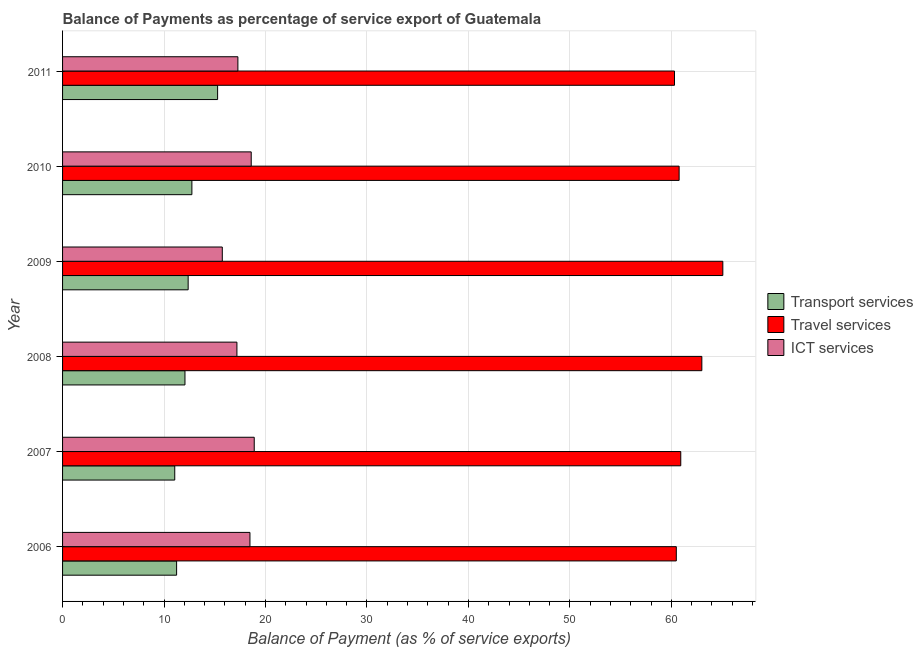How many different coloured bars are there?
Offer a very short reply. 3. How many groups of bars are there?
Provide a succinct answer. 6. Are the number of bars per tick equal to the number of legend labels?
Your answer should be very brief. Yes. Are the number of bars on each tick of the Y-axis equal?
Keep it short and to the point. Yes. How many bars are there on the 2nd tick from the top?
Make the answer very short. 3. What is the label of the 3rd group of bars from the top?
Your answer should be very brief. 2009. In how many cases, is the number of bars for a given year not equal to the number of legend labels?
Your answer should be compact. 0. What is the balance of payment of travel services in 2011?
Your response must be concise. 60.31. Across all years, what is the maximum balance of payment of transport services?
Make the answer very short. 15.28. Across all years, what is the minimum balance of payment of transport services?
Keep it short and to the point. 11.06. In which year was the balance of payment of ict services minimum?
Give a very brief answer. 2009. What is the total balance of payment of transport services in the graph?
Provide a short and direct response. 74.76. What is the difference between the balance of payment of transport services in 2007 and that in 2009?
Offer a terse response. -1.32. What is the difference between the balance of payment of ict services in 2008 and the balance of payment of transport services in 2011?
Provide a succinct answer. 1.9. What is the average balance of payment of travel services per year?
Provide a short and direct response. 61.76. In the year 2006, what is the difference between the balance of payment of travel services and balance of payment of ict services?
Make the answer very short. 42.02. Is the difference between the balance of payment of travel services in 2007 and 2008 greater than the difference between the balance of payment of ict services in 2007 and 2008?
Offer a very short reply. No. What is the difference between the highest and the second highest balance of payment of ict services?
Provide a short and direct response. 0.3. What is the difference between the highest and the lowest balance of payment of travel services?
Keep it short and to the point. 4.76. Is the sum of the balance of payment of ict services in 2006 and 2007 greater than the maximum balance of payment of travel services across all years?
Give a very brief answer. No. What does the 2nd bar from the top in 2009 represents?
Give a very brief answer. Travel services. What does the 3rd bar from the bottom in 2010 represents?
Provide a succinct answer. ICT services. How many bars are there?
Keep it short and to the point. 18. What is the difference between two consecutive major ticks on the X-axis?
Provide a short and direct response. 10. Does the graph contain any zero values?
Your response must be concise. No. Does the graph contain grids?
Your answer should be compact. Yes. Where does the legend appear in the graph?
Provide a short and direct response. Center right. How many legend labels are there?
Provide a succinct answer. 3. What is the title of the graph?
Offer a terse response. Balance of Payments as percentage of service export of Guatemala. What is the label or title of the X-axis?
Your response must be concise. Balance of Payment (as % of service exports). What is the Balance of Payment (as % of service exports) of Transport services in 2006?
Ensure brevity in your answer.  11.24. What is the Balance of Payment (as % of service exports) of Travel services in 2006?
Your answer should be compact. 60.48. What is the Balance of Payment (as % of service exports) of ICT services in 2006?
Offer a terse response. 18.47. What is the Balance of Payment (as % of service exports) of Transport services in 2007?
Offer a very short reply. 11.06. What is the Balance of Payment (as % of service exports) of Travel services in 2007?
Your response must be concise. 60.92. What is the Balance of Payment (as % of service exports) of ICT services in 2007?
Keep it short and to the point. 18.89. What is the Balance of Payment (as % of service exports) of Transport services in 2008?
Provide a short and direct response. 12.06. What is the Balance of Payment (as % of service exports) of Travel services in 2008?
Keep it short and to the point. 63. What is the Balance of Payment (as % of service exports) in ICT services in 2008?
Offer a very short reply. 17.18. What is the Balance of Payment (as % of service exports) of Transport services in 2009?
Provide a short and direct response. 12.38. What is the Balance of Payment (as % of service exports) of Travel services in 2009?
Make the answer very short. 65.07. What is the Balance of Payment (as % of service exports) of ICT services in 2009?
Offer a very short reply. 15.74. What is the Balance of Payment (as % of service exports) of Transport services in 2010?
Offer a terse response. 12.74. What is the Balance of Payment (as % of service exports) of Travel services in 2010?
Your response must be concise. 60.76. What is the Balance of Payment (as % of service exports) in ICT services in 2010?
Your answer should be compact. 18.59. What is the Balance of Payment (as % of service exports) in Transport services in 2011?
Make the answer very short. 15.28. What is the Balance of Payment (as % of service exports) in Travel services in 2011?
Keep it short and to the point. 60.31. What is the Balance of Payment (as % of service exports) of ICT services in 2011?
Provide a short and direct response. 17.28. Across all years, what is the maximum Balance of Payment (as % of service exports) of Transport services?
Provide a succinct answer. 15.28. Across all years, what is the maximum Balance of Payment (as % of service exports) of Travel services?
Offer a very short reply. 65.07. Across all years, what is the maximum Balance of Payment (as % of service exports) of ICT services?
Your response must be concise. 18.89. Across all years, what is the minimum Balance of Payment (as % of service exports) of Transport services?
Your response must be concise. 11.06. Across all years, what is the minimum Balance of Payment (as % of service exports) of Travel services?
Offer a terse response. 60.31. Across all years, what is the minimum Balance of Payment (as % of service exports) of ICT services?
Provide a short and direct response. 15.74. What is the total Balance of Payment (as % of service exports) in Transport services in the graph?
Your response must be concise. 74.76. What is the total Balance of Payment (as % of service exports) in Travel services in the graph?
Your response must be concise. 370.54. What is the total Balance of Payment (as % of service exports) of ICT services in the graph?
Ensure brevity in your answer.  106.15. What is the difference between the Balance of Payment (as % of service exports) of Transport services in 2006 and that in 2007?
Give a very brief answer. 0.18. What is the difference between the Balance of Payment (as % of service exports) of Travel services in 2006 and that in 2007?
Provide a succinct answer. -0.44. What is the difference between the Balance of Payment (as % of service exports) of ICT services in 2006 and that in 2007?
Make the answer very short. -0.42. What is the difference between the Balance of Payment (as % of service exports) of Transport services in 2006 and that in 2008?
Provide a short and direct response. -0.82. What is the difference between the Balance of Payment (as % of service exports) of Travel services in 2006 and that in 2008?
Offer a terse response. -2.52. What is the difference between the Balance of Payment (as % of service exports) of ICT services in 2006 and that in 2008?
Give a very brief answer. 1.28. What is the difference between the Balance of Payment (as % of service exports) in Transport services in 2006 and that in 2009?
Provide a short and direct response. -1.14. What is the difference between the Balance of Payment (as % of service exports) in Travel services in 2006 and that in 2009?
Ensure brevity in your answer.  -4.58. What is the difference between the Balance of Payment (as % of service exports) in ICT services in 2006 and that in 2009?
Make the answer very short. 2.73. What is the difference between the Balance of Payment (as % of service exports) of Transport services in 2006 and that in 2010?
Make the answer very short. -1.51. What is the difference between the Balance of Payment (as % of service exports) of Travel services in 2006 and that in 2010?
Keep it short and to the point. -0.28. What is the difference between the Balance of Payment (as % of service exports) of ICT services in 2006 and that in 2010?
Give a very brief answer. -0.12. What is the difference between the Balance of Payment (as % of service exports) in Transport services in 2006 and that in 2011?
Make the answer very short. -4.04. What is the difference between the Balance of Payment (as % of service exports) of Travel services in 2006 and that in 2011?
Provide a succinct answer. 0.18. What is the difference between the Balance of Payment (as % of service exports) in ICT services in 2006 and that in 2011?
Ensure brevity in your answer.  1.19. What is the difference between the Balance of Payment (as % of service exports) of Transport services in 2007 and that in 2008?
Offer a terse response. -1.01. What is the difference between the Balance of Payment (as % of service exports) of Travel services in 2007 and that in 2008?
Keep it short and to the point. -2.08. What is the difference between the Balance of Payment (as % of service exports) of ICT services in 2007 and that in 2008?
Ensure brevity in your answer.  1.71. What is the difference between the Balance of Payment (as % of service exports) of Transport services in 2007 and that in 2009?
Offer a terse response. -1.32. What is the difference between the Balance of Payment (as % of service exports) in Travel services in 2007 and that in 2009?
Your answer should be very brief. -4.14. What is the difference between the Balance of Payment (as % of service exports) of ICT services in 2007 and that in 2009?
Your response must be concise. 3.15. What is the difference between the Balance of Payment (as % of service exports) of Transport services in 2007 and that in 2010?
Provide a short and direct response. -1.69. What is the difference between the Balance of Payment (as % of service exports) of Travel services in 2007 and that in 2010?
Your response must be concise. 0.16. What is the difference between the Balance of Payment (as % of service exports) in ICT services in 2007 and that in 2010?
Your answer should be compact. 0.3. What is the difference between the Balance of Payment (as % of service exports) in Transport services in 2007 and that in 2011?
Your answer should be compact. -4.22. What is the difference between the Balance of Payment (as % of service exports) of Travel services in 2007 and that in 2011?
Offer a terse response. 0.62. What is the difference between the Balance of Payment (as % of service exports) in ICT services in 2007 and that in 2011?
Provide a succinct answer. 1.61. What is the difference between the Balance of Payment (as % of service exports) in Transport services in 2008 and that in 2009?
Ensure brevity in your answer.  -0.31. What is the difference between the Balance of Payment (as % of service exports) in Travel services in 2008 and that in 2009?
Provide a succinct answer. -2.07. What is the difference between the Balance of Payment (as % of service exports) of ICT services in 2008 and that in 2009?
Offer a terse response. 1.44. What is the difference between the Balance of Payment (as % of service exports) of Transport services in 2008 and that in 2010?
Give a very brief answer. -0.68. What is the difference between the Balance of Payment (as % of service exports) of Travel services in 2008 and that in 2010?
Offer a very short reply. 2.24. What is the difference between the Balance of Payment (as % of service exports) in ICT services in 2008 and that in 2010?
Offer a terse response. -1.41. What is the difference between the Balance of Payment (as % of service exports) of Transport services in 2008 and that in 2011?
Offer a very short reply. -3.22. What is the difference between the Balance of Payment (as % of service exports) in Travel services in 2008 and that in 2011?
Your response must be concise. 2.69. What is the difference between the Balance of Payment (as % of service exports) of ICT services in 2008 and that in 2011?
Offer a very short reply. -0.09. What is the difference between the Balance of Payment (as % of service exports) in Transport services in 2009 and that in 2010?
Provide a short and direct response. -0.37. What is the difference between the Balance of Payment (as % of service exports) of Travel services in 2009 and that in 2010?
Offer a very short reply. 4.31. What is the difference between the Balance of Payment (as % of service exports) in ICT services in 2009 and that in 2010?
Offer a terse response. -2.85. What is the difference between the Balance of Payment (as % of service exports) of Transport services in 2009 and that in 2011?
Ensure brevity in your answer.  -2.9. What is the difference between the Balance of Payment (as % of service exports) in Travel services in 2009 and that in 2011?
Give a very brief answer. 4.76. What is the difference between the Balance of Payment (as % of service exports) in ICT services in 2009 and that in 2011?
Keep it short and to the point. -1.54. What is the difference between the Balance of Payment (as % of service exports) in Transport services in 2010 and that in 2011?
Ensure brevity in your answer.  -2.53. What is the difference between the Balance of Payment (as % of service exports) of Travel services in 2010 and that in 2011?
Ensure brevity in your answer.  0.46. What is the difference between the Balance of Payment (as % of service exports) of ICT services in 2010 and that in 2011?
Offer a terse response. 1.31. What is the difference between the Balance of Payment (as % of service exports) in Transport services in 2006 and the Balance of Payment (as % of service exports) in Travel services in 2007?
Provide a succinct answer. -49.68. What is the difference between the Balance of Payment (as % of service exports) of Transport services in 2006 and the Balance of Payment (as % of service exports) of ICT services in 2007?
Your answer should be compact. -7.65. What is the difference between the Balance of Payment (as % of service exports) of Travel services in 2006 and the Balance of Payment (as % of service exports) of ICT services in 2007?
Make the answer very short. 41.6. What is the difference between the Balance of Payment (as % of service exports) of Transport services in 2006 and the Balance of Payment (as % of service exports) of Travel services in 2008?
Ensure brevity in your answer.  -51.76. What is the difference between the Balance of Payment (as % of service exports) in Transport services in 2006 and the Balance of Payment (as % of service exports) in ICT services in 2008?
Provide a short and direct response. -5.95. What is the difference between the Balance of Payment (as % of service exports) of Travel services in 2006 and the Balance of Payment (as % of service exports) of ICT services in 2008?
Your response must be concise. 43.3. What is the difference between the Balance of Payment (as % of service exports) in Transport services in 2006 and the Balance of Payment (as % of service exports) in Travel services in 2009?
Ensure brevity in your answer.  -53.83. What is the difference between the Balance of Payment (as % of service exports) in Transport services in 2006 and the Balance of Payment (as % of service exports) in ICT services in 2009?
Ensure brevity in your answer.  -4.5. What is the difference between the Balance of Payment (as % of service exports) of Travel services in 2006 and the Balance of Payment (as % of service exports) of ICT services in 2009?
Your answer should be compact. 44.74. What is the difference between the Balance of Payment (as % of service exports) of Transport services in 2006 and the Balance of Payment (as % of service exports) of Travel services in 2010?
Provide a succinct answer. -49.52. What is the difference between the Balance of Payment (as % of service exports) in Transport services in 2006 and the Balance of Payment (as % of service exports) in ICT services in 2010?
Your answer should be very brief. -7.35. What is the difference between the Balance of Payment (as % of service exports) in Travel services in 2006 and the Balance of Payment (as % of service exports) in ICT services in 2010?
Ensure brevity in your answer.  41.89. What is the difference between the Balance of Payment (as % of service exports) of Transport services in 2006 and the Balance of Payment (as % of service exports) of Travel services in 2011?
Make the answer very short. -49.07. What is the difference between the Balance of Payment (as % of service exports) of Transport services in 2006 and the Balance of Payment (as % of service exports) of ICT services in 2011?
Your answer should be compact. -6.04. What is the difference between the Balance of Payment (as % of service exports) of Travel services in 2006 and the Balance of Payment (as % of service exports) of ICT services in 2011?
Offer a very short reply. 43.21. What is the difference between the Balance of Payment (as % of service exports) of Transport services in 2007 and the Balance of Payment (as % of service exports) of Travel services in 2008?
Provide a short and direct response. -51.94. What is the difference between the Balance of Payment (as % of service exports) in Transport services in 2007 and the Balance of Payment (as % of service exports) in ICT services in 2008?
Give a very brief answer. -6.13. What is the difference between the Balance of Payment (as % of service exports) of Travel services in 2007 and the Balance of Payment (as % of service exports) of ICT services in 2008?
Give a very brief answer. 43.74. What is the difference between the Balance of Payment (as % of service exports) in Transport services in 2007 and the Balance of Payment (as % of service exports) in Travel services in 2009?
Provide a short and direct response. -54.01. What is the difference between the Balance of Payment (as % of service exports) in Transport services in 2007 and the Balance of Payment (as % of service exports) in ICT services in 2009?
Your answer should be very brief. -4.69. What is the difference between the Balance of Payment (as % of service exports) of Travel services in 2007 and the Balance of Payment (as % of service exports) of ICT services in 2009?
Give a very brief answer. 45.18. What is the difference between the Balance of Payment (as % of service exports) of Transport services in 2007 and the Balance of Payment (as % of service exports) of Travel services in 2010?
Your answer should be compact. -49.71. What is the difference between the Balance of Payment (as % of service exports) in Transport services in 2007 and the Balance of Payment (as % of service exports) in ICT services in 2010?
Provide a succinct answer. -7.54. What is the difference between the Balance of Payment (as % of service exports) in Travel services in 2007 and the Balance of Payment (as % of service exports) in ICT services in 2010?
Offer a very short reply. 42.33. What is the difference between the Balance of Payment (as % of service exports) in Transport services in 2007 and the Balance of Payment (as % of service exports) in Travel services in 2011?
Your response must be concise. -49.25. What is the difference between the Balance of Payment (as % of service exports) in Transport services in 2007 and the Balance of Payment (as % of service exports) in ICT services in 2011?
Provide a short and direct response. -6.22. What is the difference between the Balance of Payment (as % of service exports) in Travel services in 2007 and the Balance of Payment (as % of service exports) in ICT services in 2011?
Your answer should be very brief. 43.64. What is the difference between the Balance of Payment (as % of service exports) in Transport services in 2008 and the Balance of Payment (as % of service exports) in Travel services in 2009?
Offer a very short reply. -53.01. What is the difference between the Balance of Payment (as % of service exports) in Transport services in 2008 and the Balance of Payment (as % of service exports) in ICT services in 2009?
Give a very brief answer. -3.68. What is the difference between the Balance of Payment (as % of service exports) of Travel services in 2008 and the Balance of Payment (as % of service exports) of ICT services in 2009?
Your answer should be compact. 47.26. What is the difference between the Balance of Payment (as % of service exports) of Transport services in 2008 and the Balance of Payment (as % of service exports) of Travel services in 2010?
Provide a succinct answer. -48.7. What is the difference between the Balance of Payment (as % of service exports) of Transport services in 2008 and the Balance of Payment (as % of service exports) of ICT services in 2010?
Offer a terse response. -6.53. What is the difference between the Balance of Payment (as % of service exports) of Travel services in 2008 and the Balance of Payment (as % of service exports) of ICT services in 2010?
Offer a terse response. 44.41. What is the difference between the Balance of Payment (as % of service exports) in Transport services in 2008 and the Balance of Payment (as % of service exports) in Travel services in 2011?
Offer a very short reply. -48.24. What is the difference between the Balance of Payment (as % of service exports) in Transport services in 2008 and the Balance of Payment (as % of service exports) in ICT services in 2011?
Give a very brief answer. -5.22. What is the difference between the Balance of Payment (as % of service exports) in Travel services in 2008 and the Balance of Payment (as % of service exports) in ICT services in 2011?
Offer a very short reply. 45.72. What is the difference between the Balance of Payment (as % of service exports) in Transport services in 2009 and the Balance of Payment (as % of service exports) in Travel services in 2010?
Provide a short and direct response. -48.39. What is the difference between the Balance of Payment (as % of service exports) of Transport services in 2009 and the Balance of Payment (as % of service exports) of ICT services in 2010?
Your response must be concise. -6.21. What is the difference between the Balance of Payment (as % of service exports) in Travel services in 2009 and the Balance of Payment (as % of service exports) in ICT services in 2010?
Your answer should be very brief. 46.48. What is the difference between the Balance of Payment (as % of service exports) in Transport services in 2009 and the Balance of Payment (as % of service exports) in Travel services in 2011?
Ensure brevity in your answer.  -47.93. What is the difference between the Balance of Payment (as % of service exports) in Transport services in 2009 and the Balance of Payment (as % of service exports) in ICT services in 2011?
Your answer should be very brief. -4.9. What is the difference between the Balance of Payment (as % of service exports) in Travel services in 2009 and the Balance of Payment (as % of service exports) in ICT services in 2011?
Ensure brevity in your answer.  47.79. What is the difference between the Balance of Payment (as % of service exports) of Transport services in 2010 and the Balance of Payment (as % of service exports) of Travel services in 2011?
Keep it short and to the point. -47.56. What is the difference between the Balance of Payment (as % of service exports) of Transport services in 2010 and the Balance of Payment (as % of service exports) of ICT services in 2011?
Your response must be concise. -4.53. What is the difference between the Balance of Payment (as % of service exports) in Travel services in 2010 and the Balance of Payment (as % of service exports) in ICT services in 2011?
Your answer should be very brief. 43.48. What is the average Balance of Payment (as % of service exports) in Transport services per year?
Offer a terse response. 12.46. What is the average Balance of Payment (as % of service exports) of Travel services per year?
Offer a very short reply. 61.76. What is the average Balance of Payment (as % of service exports) in ICT services per year?
Offer a very short reply. 17.69. In the year 2006, what is the difference between the Balance of Payment (as % of service exports) of Transport services and Balance of Payment (as % of service exports) of Travel services?
Keep it short and to the point. -49.25. In the year 2006, what is the difference between the Balance of Payment (as % of service exports) of Transport services and Balance of Payment (as % of service exports) of ICT services?
Make the answer very short. -7.23. In the year 2006, what is the difference between the Balance of Payment (as % of service exports) in Travel services and Balance of Payment (as % of service exports) in ICT services?
Offer a very short reply. 42.02. In the year 2007, what is the difference between the Balance of Payment (as % of service exports) of Transport services and Balance of Payment (as % of service exports) of Travel services?
Your response must be concise. -49.87. In the year 2007, what is the difference between the Balance of Payment (as % of service exports) in Transport services and Balance of Payment (as % of service exports) in ICT services?
Ensure brevity in your answer.  -7.83. In the year 2007, what is the difference between the Balance of Payment (as % of service exports) of Travel services and Balance of Payment (as % of service exports) of ICT services?
Your response must be concise. 42.03. In the year 2008, what is the difference between the Balance of Payment (as % of service exports) in Transport services and Balance of Payment (as % of service exports) in Travel services?
Ensure brevity in your answer.  -50.94. In the year 2008, what is the difference between the Balance of Payment (as % of service exports) in Transport services and Balance of Payment (as % of service exports) in ICT services?
Offer a terse response. -5.12. In the year 2008, what is the difference between the Balance of Payment (as % of service exports) in Travel services and Balance of Payment (as % of service exports) in ICT services?
Your response must be concise. 45.82. In the year 2009, what is the difference between the Balance of Payment (as % of service exports) of Transport services and Balance of Payment (as % of service exports) of Travel services?
Your answer should be compact. -52.69. In the year 2009, what is the difference between the Balance of Payment (as % of service exports) in Transport services and Balance of Payment (as % of service exports) in ICT services?
Your response must be concise. -3.36. In the year 2009, what is the difference between the Balance of Payment (as % of service exports) in Travel services and Balance of Payment (as % of service exports) in ICT services?
Provide a succinct answer. 49.33. In the year 2010, what is the difference between the Balance of Payment (as % of service exports) in Transport services and Balance of Payment (as % of service exports) in Travel services?
Offer a very short reply. -48.02. In the year 2010, what is the difference between the Balance of Payment (as % of service exports) of Transport services and Balance of Payment (as % of service exports) of ICT services?
Provide a short and direct response. -5.85. In the year 2010, what is the difference between the Balance of Payment (as % of service exports) of Travel services and Balance of Payment (as % of service exports) of ICT services?
Ensure brevity in your answer.  42.17. In the year 2011, what is the difference between the Balance of Payment (as % of service exports) of Transport services and Balance of Payment (as % of service exports) of Travel services?
Your answer should be very brief. -45.03. In the year 2011, what is the difference between the Balance of Payment (as % of service exports) in Transport services and Balance of Payment (as % of service exports) in ICT services?
Make the answer very short. -2. In the year 2011, what is the difference between the Balance of Payment (as % of service exports) in Travel services and Balance of Payment (as % of service exports) in ICT services?
Offer a terse response. 43.03. What is the ratio of the Balance of Payment (as % of service exports) in Transport services in 2006 to that in 2007?
Ensure brevity in your answer.  1.02. What is the ratio of the Balance of Payment (as % of service exports) in Travel services in 2006 to that in 2007?
Your answer should be very brief. 0.99. What is the ratio of the Balance of Payment (as % of service exports) in ICT services in 2006 to that in 2007?
Keep it short and to the point. 0.98. What is the ratio of the Balance of Payment (as % of service exports) of Transport services in 2006 to that in 2008?
Your answer should be compact. 0.93. What is the ratio of the Balance of Payment (as % of service exports) in Travel services in 2006 to that in 2008?
Your answer should be compact. 0.96. What is the ratio of the Balance of Payment (as % of service exports) in ICT services in 2006 to that in 2008?
Your answer should be compact. 1.07. What is the ratio of the Balance of Payment (as % of service exports) in Transport services in 2006 to that in 2009?
Ensure brevity in your answer.  0.91. What is the ratio of the Balance of Payment (as % of service exports) of Travel services in 2006 to that in 2009?
Make the answer very short. 0.93. What is the ratio of the Balance of Payment (as % of service exports) in ICT services in 2006 to that in 2009?
Offer a very short reply. 1.17. What is the ratio of the Balance of Payment (as % of service exports) of Transport services in 2006 to that in 2010?
Provide a succinct answer. 0.88. What is the ratio of the Balance of Payment (as % of service exports) of Travel services in 2006 to that in 2010?
Make the answer very short. 1. What is the ratio of the Balance of Payment (as % of service exports) of ICT services in 2006 to that in 2010?
Keep it short and to the point. 0.99. What is the ratio of the Balance of Payment (as % of service exports) of Transport services in 2006 to that in 2011?
Your response must be concise. 0.74. What is the ratio of the Balance of Payment (as % of service exports) in Travel services in 2006 to that in 2011?
Make the answer very short. 1. What is the ratio of the Balance of Payment (as % of service exports) in ICT services in 2006 to that in 2011?
Offer a terse response. 1.07. What is the ratio of the Balance of Payment (as % of service exports) in Transport services in 2007 to that in 2008?
Provide a succinct answer. 0.92. What is the ratio of the Balance of Payment (as % of service exports) of Travel services in 2007 to that in 2008?
Your answer should be compact. 0.97. What is the ratio of the Balance of Payment (as % of service exports) of ICT services in 2007 to that in 2008?
Your answer should be compact. 1.1. What is the ratio of the Balance of Payment (as % of service exports) of Transport services in 2007 to that in 2009?
Provide a short and direct response. 0.89. What is the ratio of the Balance of Payment (as % of service exports) of Travel services in 2007 to that in 2009?
Provide a short and direct response. 0.94. What is the ratio of the Balance of Payment (as % of service exports) in ICT services in 2007 to that in 2009?
Provide a succinct answer. 1.2. What is the ratio of the Balance of Payment (as % of service exports) of Transport services in 2007 to that in 2010?
Offer a terse response. 0.87. What is the ratio of the Balance of Payment (as % of service exports) in Travel services in 2007 to that in 2010?
Your answer should be very brief. 1. What is the ratio of the Balance of Payment (as % of service exports) in ICT services in 2007 to that in 2010?
Provide a succinct answer. 1.02. What is the ratio of the Balance of Payment (as % of service exports) in Transport services in 2007 to that in 2011?
Your answer should be very brief. 0.72. What is the ratio of the Balance of Payment (as % of service exports) in Travel services in 2007 to that in 2011?
Provide a short and direct response. 1.01. What is the ratio of the Balance of Payment (as % of service exports) of ICT services in 2007 to that in 2011?
Your answer should be compact. 1.09. What is the ratio of the Balance of Payment (as % of service exports) in Transport services in 2008 to that in 2009?
Offer a terse response. 0.97. What is the ratio of the Balance of Payment (as % of service exports) of Travel services in 2008 to that in 2009?
Provide a succinct answer. 0.97. What is the ratio of the Balance of Payment (as % of service exports) of ICT services in 2008 to that in 2009?
Keep it short and to the point. 1.09. What is the ratio of the Balance of Payment (as % of service exports) in Transport services in 2008 to that in 2010?
Provide a short and direct response. 0.95. What is the ratio of the Balance of Payment (as % of service exports) in Travel services in 2008 to that in 2010?
Provide a short and direct response. 1.04. What is the ratio of the Balance of Payment (as % of service exports) of ICT services in 2008 to that in 2010?
Give a very brief answer. 0.92. What is the ratio of the Balance of Payment (as % of service exports) in Transport services in 2008 to that in 2011?
Your response must be concise. 0.79. What is the ratio of the Balance of Payment (as % of service exports) in Travel services in 2008 to that in 2011?
Ensure brevity in your answer.  1.04. What is the ratio of the Balance of Payment (as % of service exports) of Transport services in 2009 to that in 2010?
Your answer should be very brief. 0.97. What is the ratio of the Balance of Payment (as % of service exports) in Travel services in 2009 to that in 2010?
Offer a very short reply. 1.07. What is the ratio of the Balance of Payment (as % of service exports) of ICT services in 2009 to that in 2010?
Your answer should be compact. 0.85. What is the ratio of the Balance of Payment (as % of service exports) in Transport services in 2009 to that in 2011?
Ensure brevity in your answer.  0.81. What is the ratio of the Balance of Payment (as % of service exports) in Travel services in 2009 to that in 2011?
Give a very brief answer. 1.08. What is the ratio of the Balance of Payment (as % of service exports) in ICT services in 2009 to that in 2011?
Provide a succinct answer. 0.91. What is the ratio of the Balance of Payment (as % of service exports) in Transport services in 2010 to that in 2011?
Your answer should be very brief. 0.83. What is the ratio of the Balance of Payment (as % of service exports) in Travel services in 2010 to that in 2011?
Make the answer very short. 1.01. What is the ratio of the Balance of Payment (as % of service exports) in ICT services in 2010 to that in 2011?
Give a very brief answer. 1.08. What is the difference between the highest and the second highest Balance of Payment (as % of service exports) of Transport services?
Offer a very short reply. 2.53. What is the difference between the highest and the second highest Balance of Payment (as % of service exports) of Travel services?
Make the answer very short. 2.07. What is the difference between the highest and the second highest Balance of Payment (as % of service exports) of ICT services?
Offer a very short reply. 0.3. What is the difference between the highest and the lowest Balance of Payment (as % of service exports) of Transport services?
Keep it short and to the point. 4.22. What is the difference between the highest and the lowest Balance of Payment (as % of service exports) in Travel services?
Ensure brevity in your answer.  4.76. What is the difference between the highest and the lowest Balance of Payment (as % of service exports) in ICT services?
Provide a succinct answer. 3.15. 